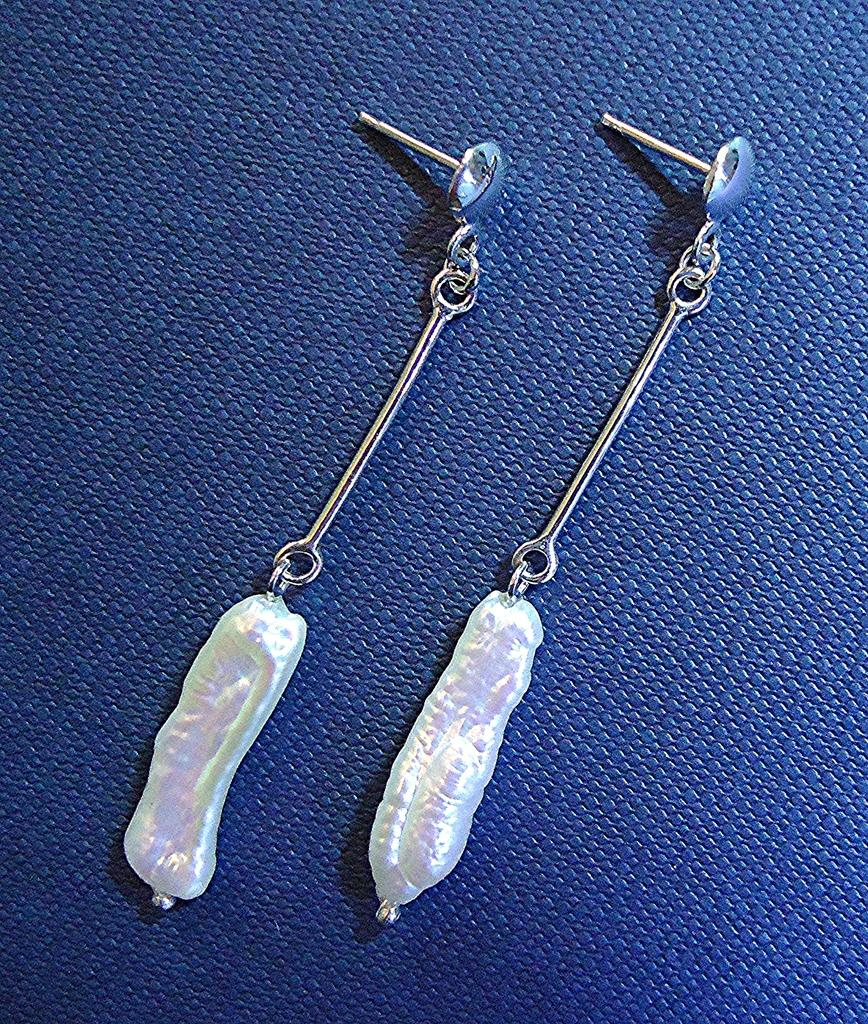What type of accessory is featured in the image? There are earrings in the image. What color is the background of the image? The background of the image is blue. Can you see a bear wearing a cap in the image? No, there is no bear or cap present in the image. 